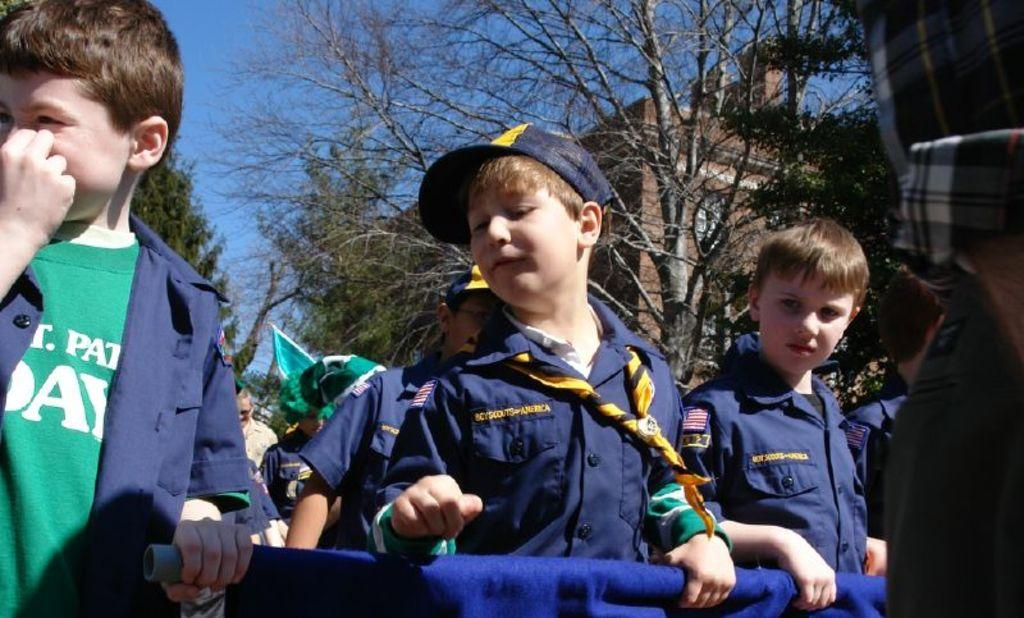How many children are in the image? There are children in the image, but the exact number is not specified. What are the children doing in the image? The children are standing on a road and holding a banner. What can be seen in the background of the image? There are trees, buildings, and the sky visible in the background of the image. What type of snake can be seen slithering on the ground in the image? There is no snake present in the image; it features children standing on a road and holding a banner. What kind of food is the children eating in the image? There is no food visible in the image; the children are holding a banner. 